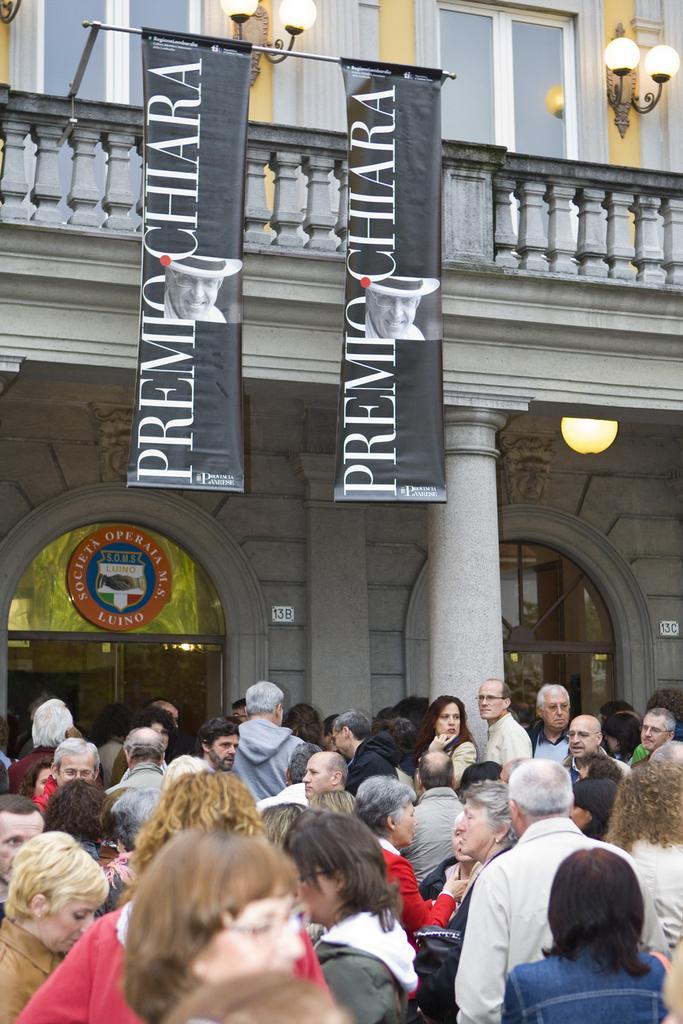Describe this image in one or two sentences. In the picture we can see many people are standing, and behind them, we can see a building with pillar and glass doors and on the top of the building we can see a two hoardings to the pole and behind it, we can see the wall with two glass windows and besides to the walls we can see the lamps. 